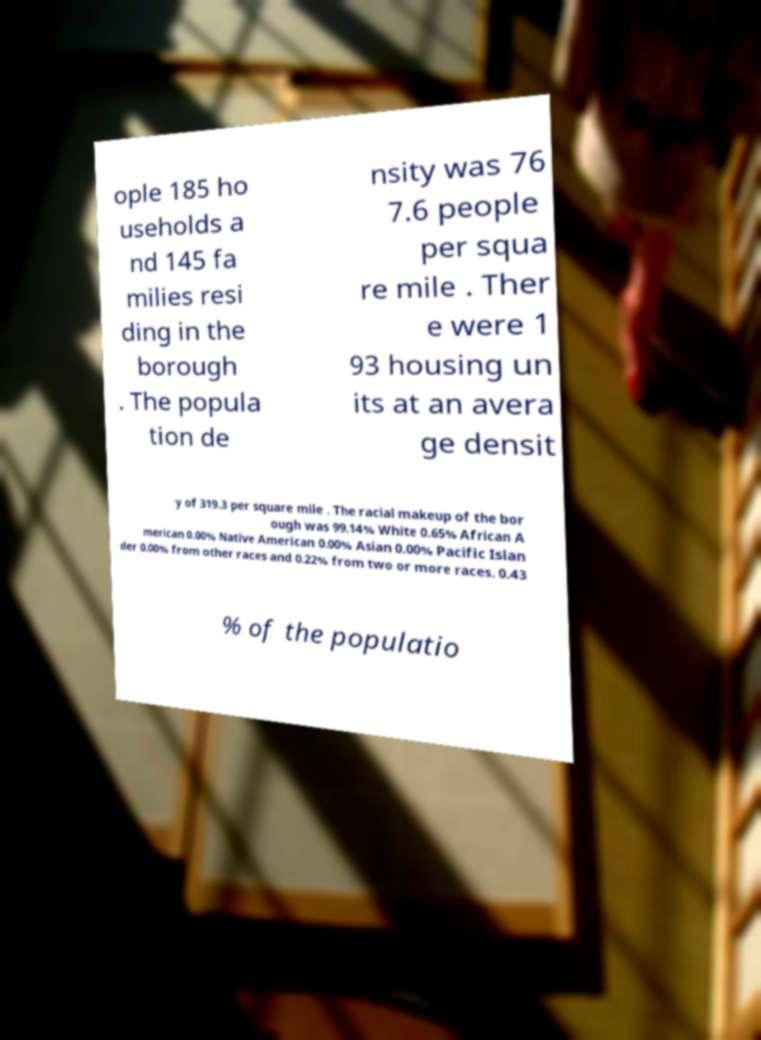Could you extract and type out the text from this image? ople 185 ho useholds a nd 145 fa milies resi ding in the borough . The popula tion de nsity was 76 7.6 people per squa re mile . Ther e were 1 93 housing un its at an avera ge densit y of 319.3 per square mile . The racial makeup of the bor ough was 99.14% White 0.65% African A merican 0.00% Native American 0.00% Asian 0.00% Pacific Islan der 0.00% from other races and 0.22% from two or more races. 0.43 % of the populatio 